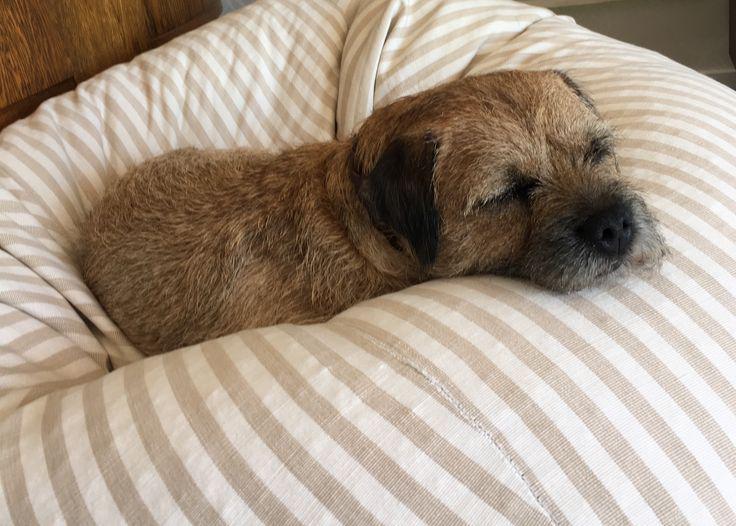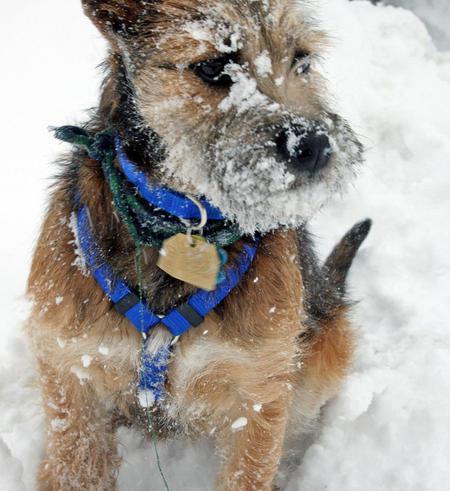The first image is the image on the left, the second image is the image on the right. For the images shown, is this caption "A black and tan dog has snow on its face." true? Answer yes or no. Yes. 